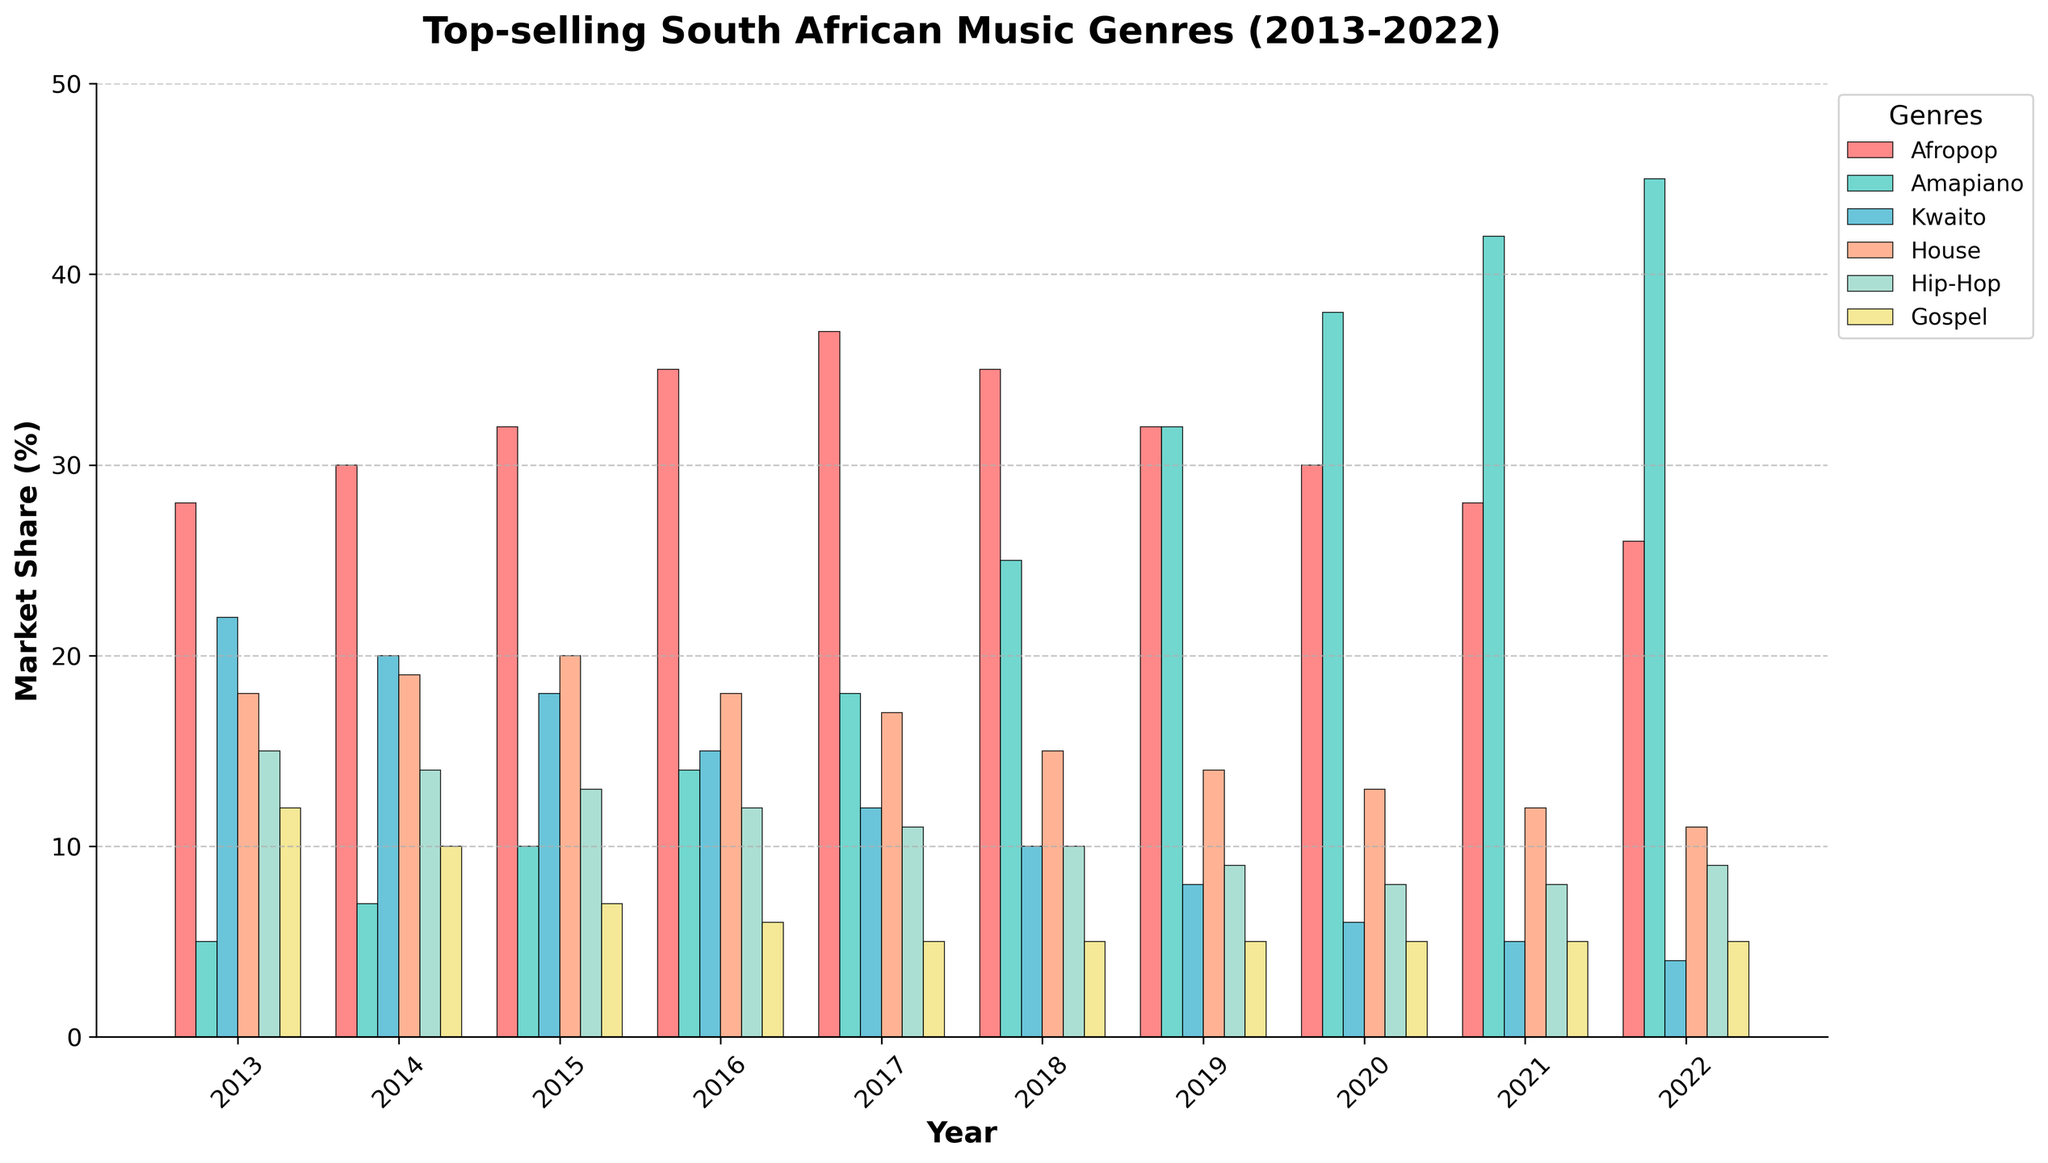Which genre saw the most significant increase in market share from 2013 to 2022? By comparing the values from 2013 to 2022, Afropop grew from 28% to 26% (which is a decrease), Amapiano grew from 5% to 45% (an increase of 40%), Kwaito decreased from 22% to 4%, House decreased from 18% to 11%, Hip-Hop decreased from 15% to 9%, and Gospel decreased from 12% to 5%. Thus, Amapiano saw the most significant increase.
Answer: Amapiano What is the difference in market share between Afropop and Amapiano in 2022? In 2022, Afropop has 26% market share, and Amapiano has 45% market share. The difference is calculated as 45% - 26%.
Answer: 19% How did the market share of House music change from 2013 to 2022? In 2013, House music had 18% market share. By 2022, it had decreased to 11%. The change is calculated as 11% - 18%.
Answer: Decreased by 7% Which year did Amapiano surpass Hip-Hop in market share for the first time? Comparing the market shares yearly, in 2015, Amapiano (10%) was still below Hip-Hop (13%). In 2016, Amapiano (14%) was slightly above Hip-Hop (12%). Thus, 2016 was the first year Amapiano surpassed Hip-Hop.
Answer: 2016 Which genre consistently had the lowest market share from 2013 to 2022? Reviewing the data for each year, Gospel consistently had the lowest market share each year, ranging between 12% in 2013 and 5% from 2016 onwards.
Answer: Gospel What is the trend in Afropop's market share from 2013 to 2022? The market share for Afropop shows a gradual increase from 28% in 2013 to a peak of 37% in 2017, followed by a steady decline to 26% in 2022.
Answer: Rising initially, then declining How did the combined market share of Kwaito and House music change from 2013 to 2022? In 2013, Kwaito had 22% and House had 18%, summing up to 40%. In 2022, Kwaito had 4% and House had 11%, summing up to 15%. The combined market share changed from 40% to 15%.
Answer: Decreased by 25% In what year did Amapiano have the highest market share, and what was the value? Amapiano had the highest market share in 2022, with a value of 45%.
Answer: 2022, 45% Compare the market share trends of Hip-Hop and Kwaito from 2013 to 2022. Hip-Hop steadily decreased from 15% to 9%, while Kwaito dropped more sharply from 22% to 4% over the same period. Both genres saw a decline, but Kwaito's decrease was more pronounced.
Answer: Both declined, Kwaito more sharply 